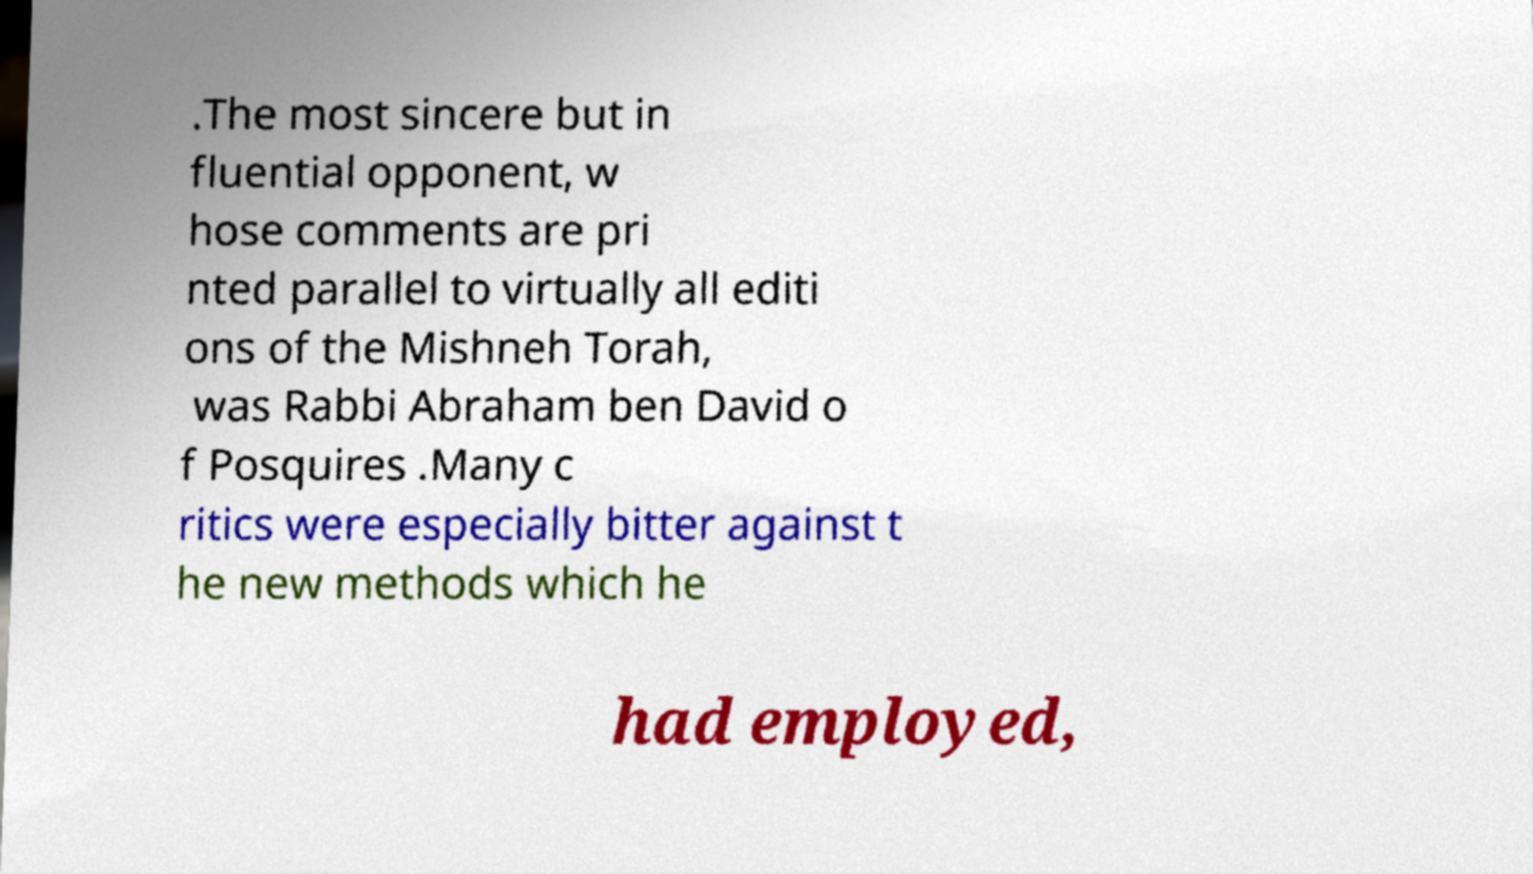I need the written content from this picture converted into text. Can you do that? .The most sincere but in fluential opponent, w hose comments are pri nted parallel to virtually all editi ons of the Mishneh Torah, was Rabbi Abraham ben David o f Posquires .Many c ritics were especially bitter against t he new methods which he had employed, 